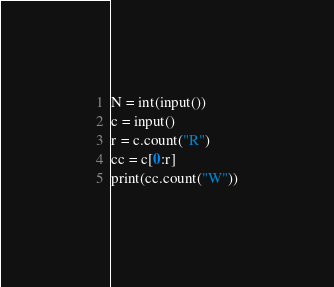<code> <loc_0><loc_0><loc_500><loc_500><_Python_>N = int(input())
c = input()
r = c.count("R")
cc = c[0:r]
print(cc.count("W"))
</code> 